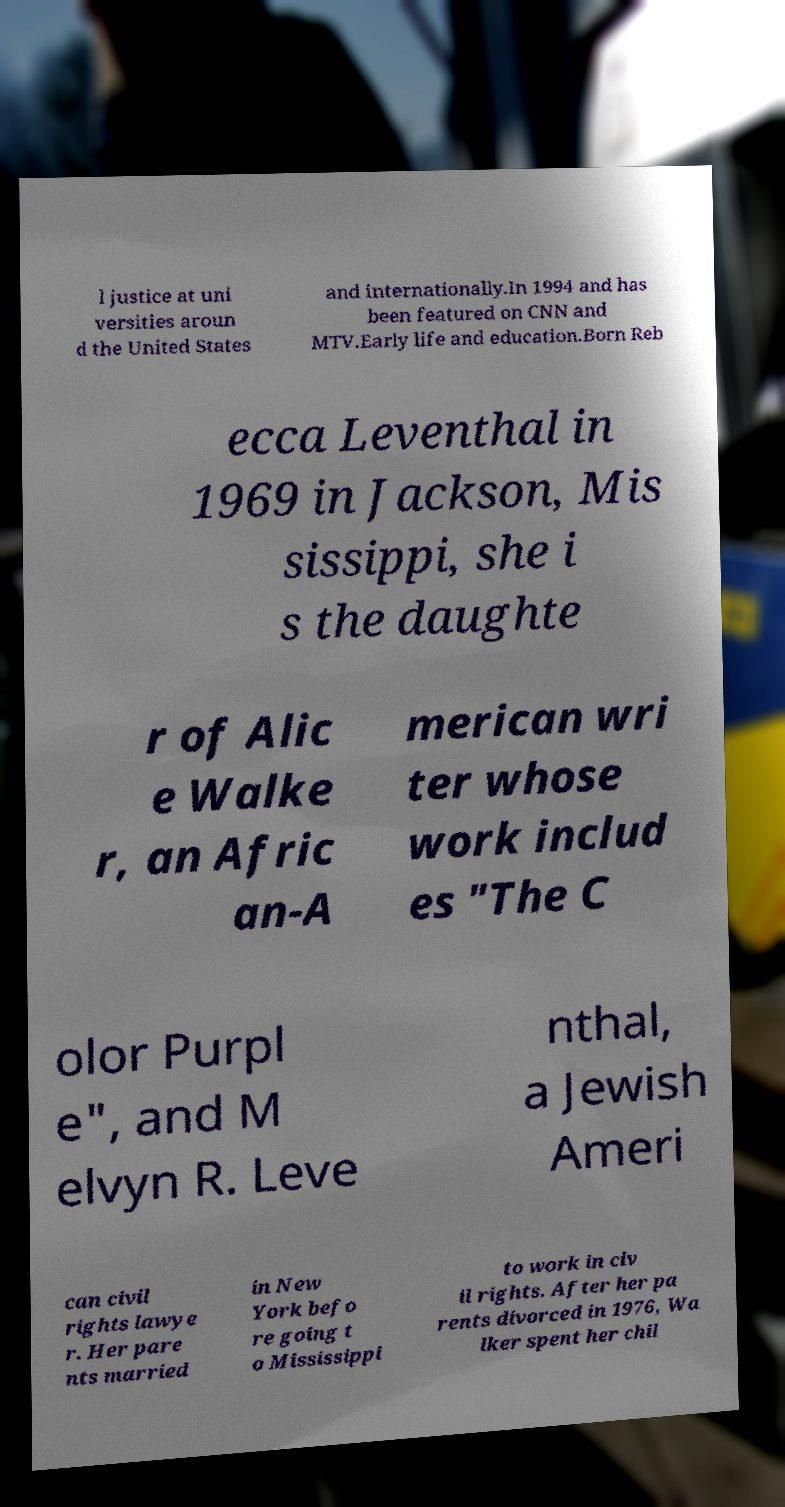Please identify and transcribe the text found in this image. l justice at uni versities aroun d the United States and internationally.In 1994 and has been featured on CNN and MTV.Early life and education.Born Reb ecca Leventhal in 1969 in Jackson, Mis sissippi, she i s the daughte r of Alic e Walke r, an Afric an-A merican wri ter whose work includ es "The C olor Purpl e", and M elvyn R. Leve nthal, a Jewish Ameri can civil rights lawye r. Her pare nts married in New York befo re going t o Mississippi to work in civ il rights. After her pa rents divorced in 1976, Wa lker spent her chil 